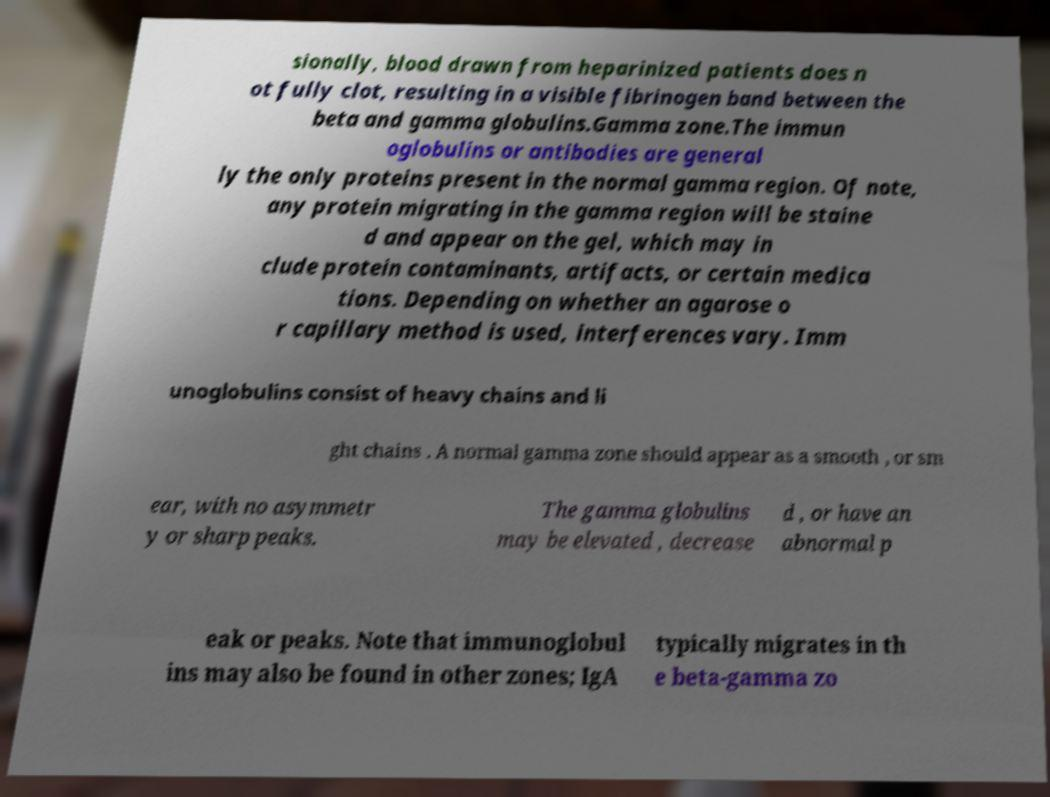There's text embedded in this image that I need extracted. Can you transcribe it verbatim? sionally, blood drawn from heparinized patients does n ot fully clot, resulting in a visible fibrinogen band between the beta and gamma globulins.Gamma zone.The immun oglobulins or antibodies are general ly the only proteins present in the normal gamma region. Of note, any protein migrating in the gamma region will be staine d and appear on the gel, which may in clude protein contaminants, artifacts, or certain medica tions. Depending on whether an agarose o r capillary method is used, interferences vary. Imm unoglobulins consist of heavy chains and li ght chains . A normal gamma zone should appear as a smooth , or sm ear, with no asymmetr y or sharp peaks. The gamma globulins may be elevated , decrease d , or have an abnormal p eak or peaks. Note that immunoglobul ins may also be found in other zones; IgA typically migrates in th e beta-gamma zo 